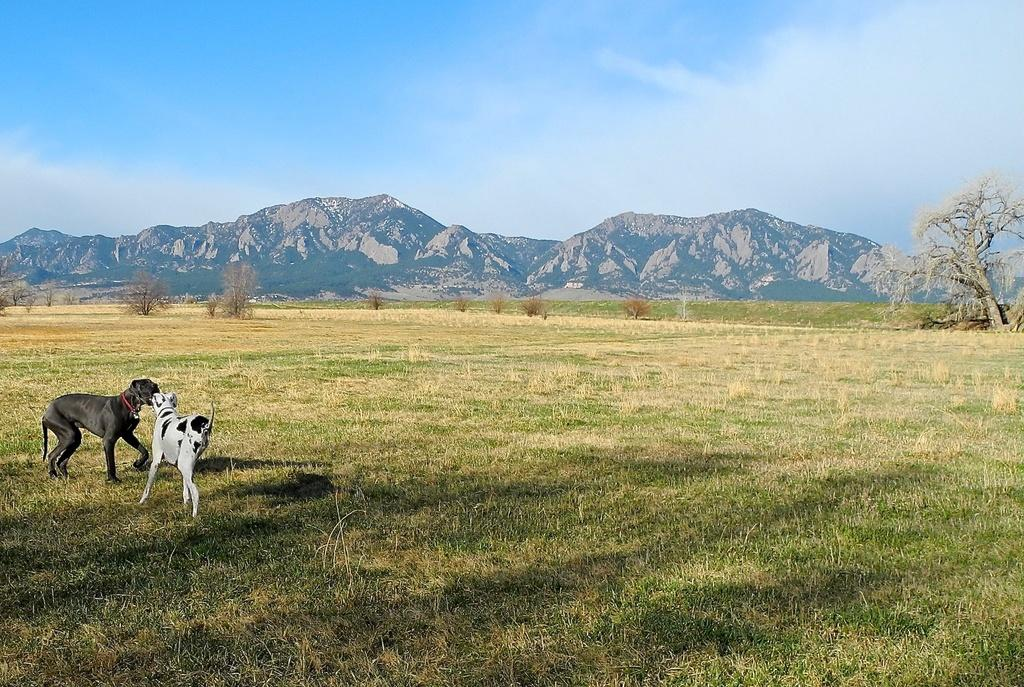What animals are on the left side of the image? There are two dogs on the left side of the image. What type of terrain is visible at the bottom of the image? There is grass at the bottom of the image. What can be seen in the background of the image? There are trees and mountains in the background of the image. What is visible at the top of the image? The sky is visible at the top of the image. What type of muscle is being exercised by the dogs in the image? The image does not show the dogs exercising any muscles; they are simply standing on the grass. 